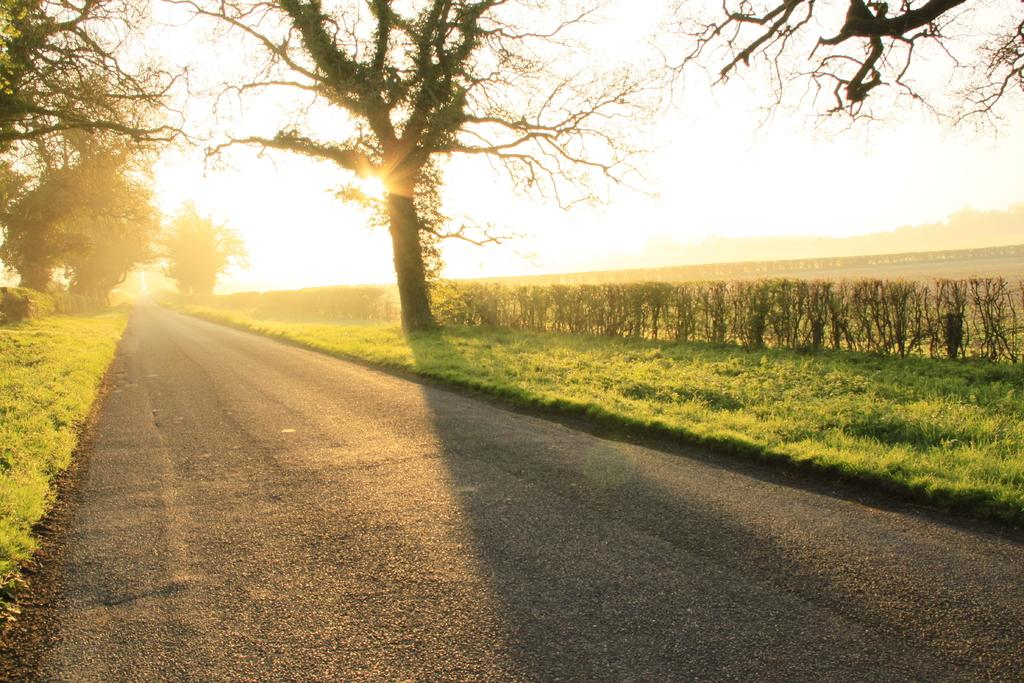What type of vegetation can be seen in the image? There are trees and plants in the image. What is the source of light in the image? There is sunlight visible in the image. What can be seen at the bottom of the image? There is a road. Can you see a coat hanging on one of the trees in the image? No, there is no coat present in the image. 